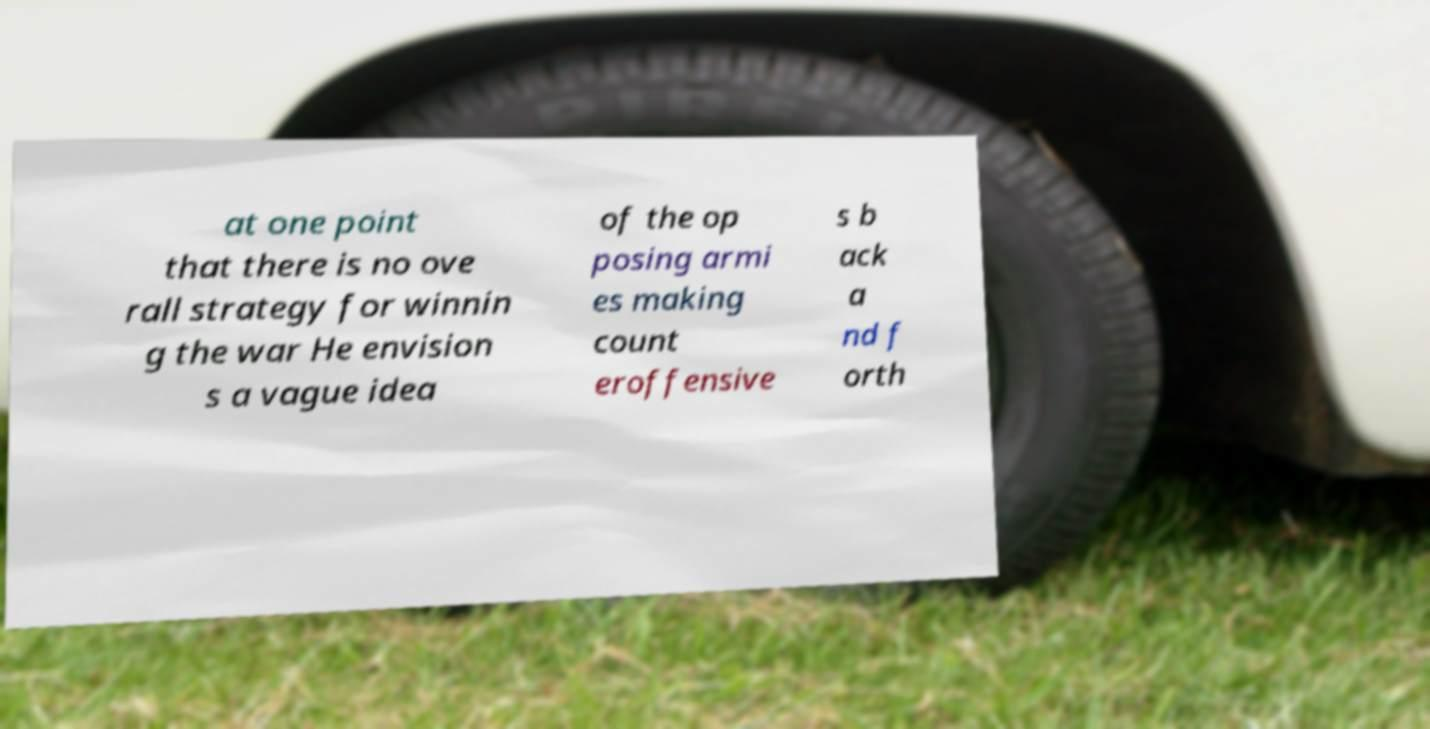Can you accurately transcribe the text from the provided image for me? at one point that there is no ove rall strategy for winnin g the war He envision s a vague idea of the op posing armi es making count eroffensive s b ack a nd f orth 